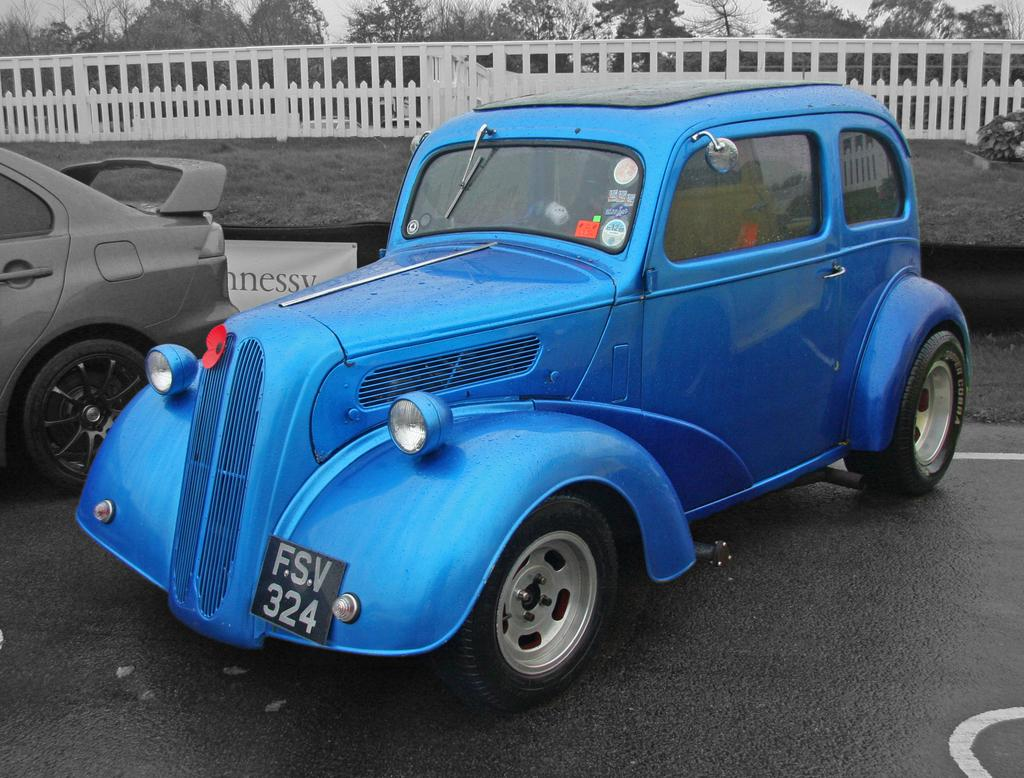How many cars are present in the image? There are two cars in the image. Where are the cars located? The cars are parked on the road. What are the colors of the cars? The cars are of different colors. What can be seen in the background of the image? There is fencing and trees visible in the background of the image. How does the glue hold the cars together in the image? There is no glue present in the image, and the cars are parked separately. 